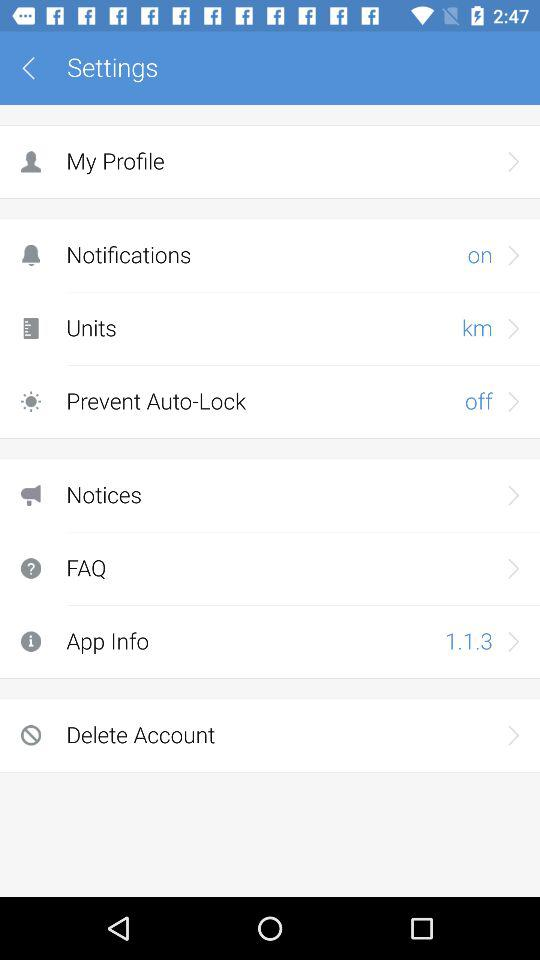What is the notification mode? The notification mode is on. 